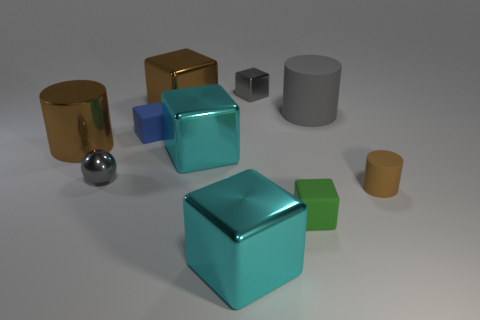Is the number of tiny gray metallic objects behind the brown metallic block greater than the number of big cyan objects that are behind the large gray rubber object? Upon careful analysis of the image, I can confirm that there are indeed more tiny gray metallic objects located behind the brown metallic block than there are large cyan objects situated behind the gray rubber object. To be precise, there is one tiny gray metallic object and no large cyan objects fitting the description provided. 